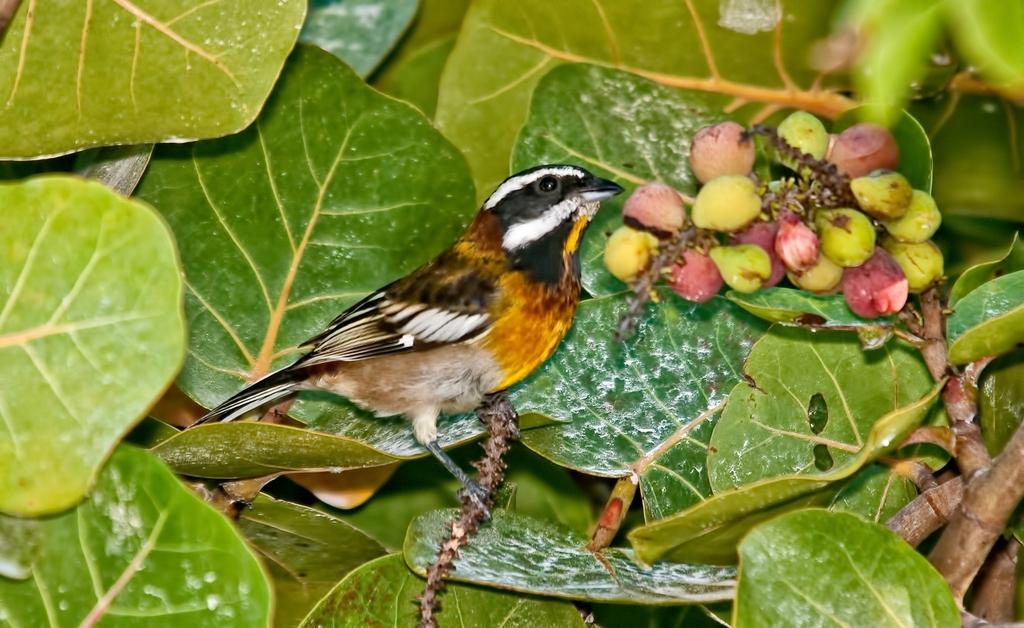What is the main subject of the image? There is a bird in the center of the image. Where is the bird located in relation to the stem? The bird is on a stem. What can be seen in the background of the image? There are leaves and fruits visible in the background of the image. What type of guide is helping the bird on the stem? There is no guide present in the image, and the bird is not interacting with any person or object. Can you tell me how many pancakes are on the bird's plate in the image? There are no pancakes or plates present in the image; it features a bird on a stem with leaves and fruits in the background. 